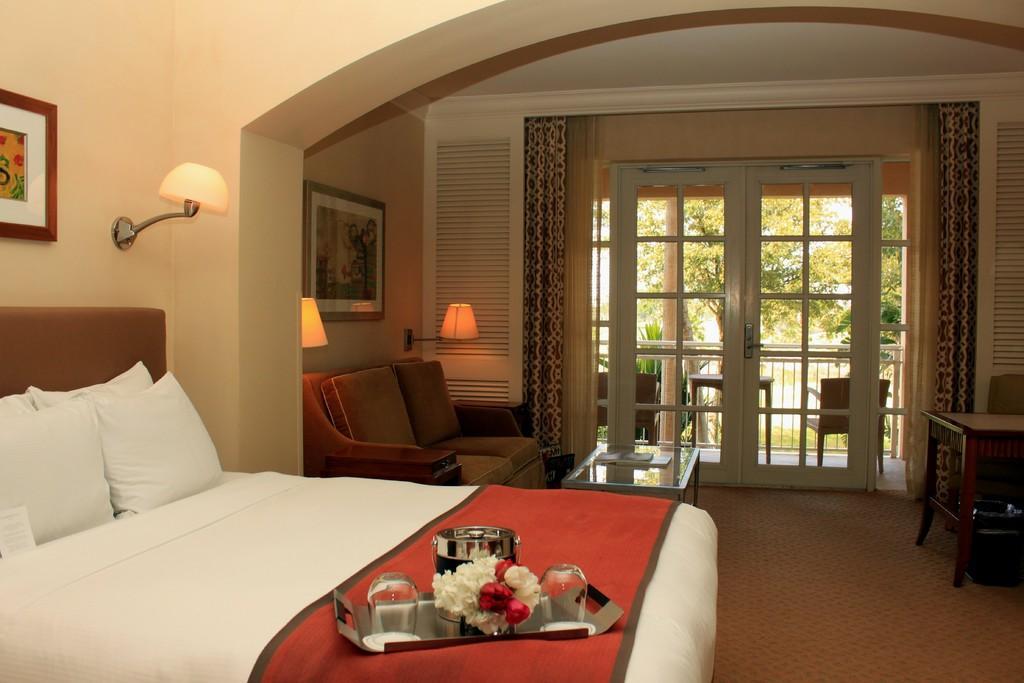Could you give a brief overview of what you see in this image? The image is taken in a room. On the left side of the image there is a bed. On the right side there is a table. In the center there is a stand next to it there is a sofa. We can also see lamps which are attached to the walls and there are photo frames. In the background there is a door and a curtain. 